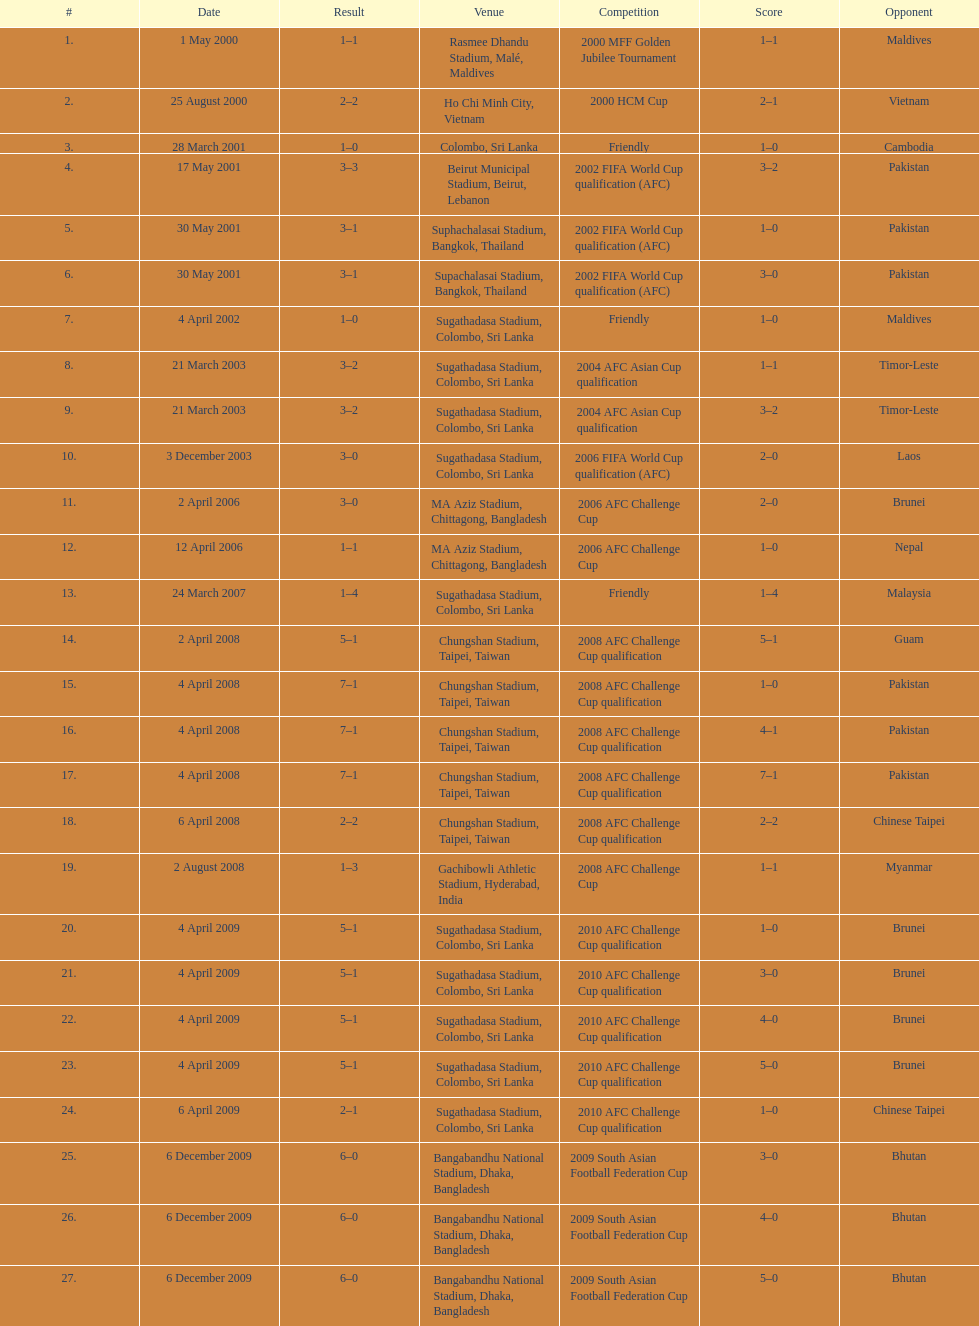What was the next venue after colombo, sri lanka on march 28? Beirut Municipal Stadium, Beirut, Lebanon. 